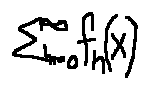Convert formula to latex. <formula><loc_0><loc_0><loc_500><loc_500>\sum \lim i t s _ { n = 0 } ^ { \infty } f _ { n } ( x )</formula> 